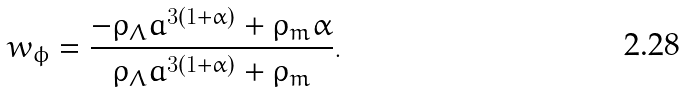<formula> <loc_0><loc_0><loc_500><loc_500>w _ { \phi } = \frac { - \rho _ { \Lambda } a ^ { 3 ( 1 + \alpha ) } + \rho _ { m } \alpha } { \rho _ { \Lambda } a ^ { 3 ( 1 + \alpha ) } + \rho _ { m } } .</formula> 